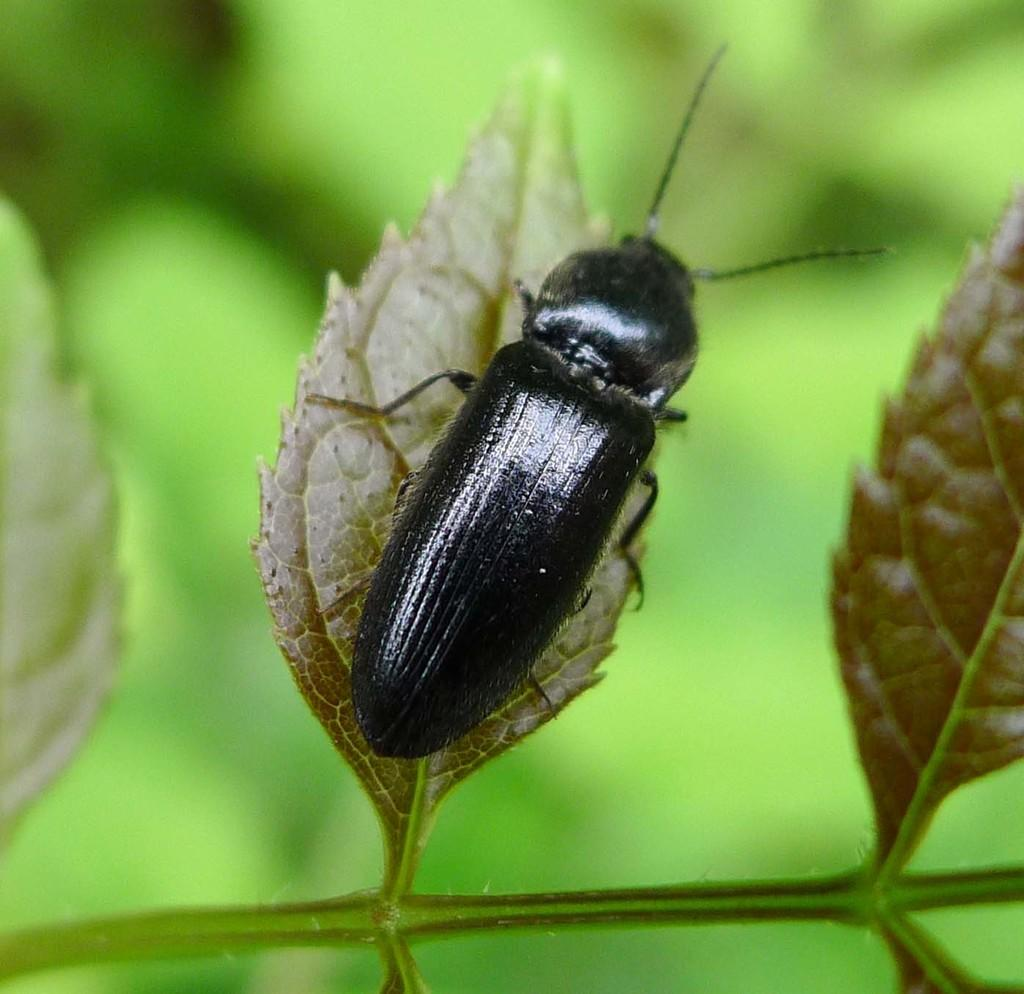What is present on the leaf in the image? There is an insect on the leaf in the image. Where is the insect located in relation to the leaf? The insect is on the leaf. What can be observed about the background of the image? The background of the image is blurred. What type of paper can be seen in the image? There is no paper present in the image; it features an insect on a leaf with a blurred background. 